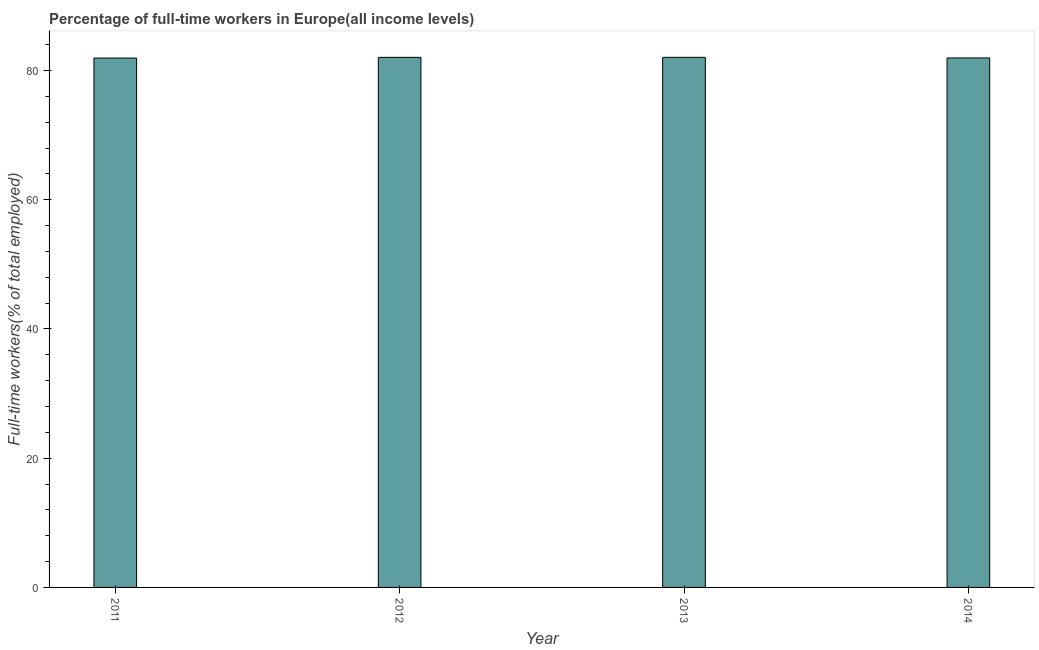Does the graph contain any zero values?
Offer a terse response. No. What is the title of the graph?
Provide a succinct answer. Percentage of full-time workers in Europe(all income levels). What is the label or title of the X-axis?
Give a very brief answer. Year. What is the label or title of the Y-axis?
Offer a terse response. Full-time workers(% of total employed). What is the percentage of full-time workers in 2011?
Provide a short and direct response. 81.93. Across all years, what is the maximum percentage of full-time workers?
Give a very brief answer. 82.04. Across all years, what is the minimum percentage of full-time workers?
Give a very brief answer. 81.93. In which year was the percentage of full-time workers minimum?
Offer a terse response. 2011. What is the sum of the percentage of full-time workers?
Your answer should be very brief. 327.96. What is the difference between the percentage of full-time workers in 2012 and 2013?
Keep it short and to the point. -0.01. What is the average percentage of full-time workers per year?
Your answer should be very brief. 81.99. What is the median percentage of full-time workers?
Provide a short and direct response. 81.99. What is the ratio of the percentage of full-time workers in 2012 to that in 2013?
Ensure brevity in your answer.  1. Is the percentage of full-time workers in 2011 less than that in 2012?
Your response must be concise. Yes. Is the difference between the percentage of full-time workers in 2011 and 2013 greater than the difference between any two years?
Provide a short and direct response. Yes. What is the difference between the highest and the second highest percentage of full-time workers?
Give a very brief answer. 0.01. What is the difference between the highest and the lowest percentage of full-time workers?
Offer a terse response. 0.11. How many bars are there?
Give a very brief answer. 4. What is the Full-time workers(% of total employed) in 2011?
Your response must be concise. 81.93. What is the Full-time workers(% of total employed) in 2012?
Provide a short and direct response. 82.04. What is the Full-time workers(% of total employed) of 2013?
Keep it short and to the point. 82.04. What is the Full-time workers(% of total employed) in 2014?
Give a very brief answer. 81.95. What is the difference between the Full-time workers(% of total employed) in 2011 and 2012?
Give a very brief answer. -0.11. What is the difference between the Full-time workers(% of total employed) in 2011 and 2013?
Offer a very short reply. -0.11. What is the difference between the Full-time workers(% of total employed) in 2011 and 2014?
Your answer should be very brief. -0.02. What is the difference between the Full-time workers(% of total employed) in 2012 and 2013?
Provide a succinct answer. -0.01. What is the difference between the Full-time workers(% of total employed) in 2012 and 2014?
Give a very brief answer. 0.09. What is the difference between the Full-time workers(% of total employed) in 2013 and 2014?
Your response must be concise. 0.09. What is the ratio of the Full-time workers(% of total employed) in 2011 to that in 2014?
Make the answer very short. 1. What is the ratio of the Full-time workers(% of total employed) in 2012 to that in 2013?
Provide a short and direct response. 1. What is the ratio of the Full-time workers(% of total employed) in 2012 to that in 2014?
Keep it short and to the point. 1. What is the ratio of the Full-time workers(% of total employed) in 2013 to that in 2014?
Keep it short and to the point. 1. 